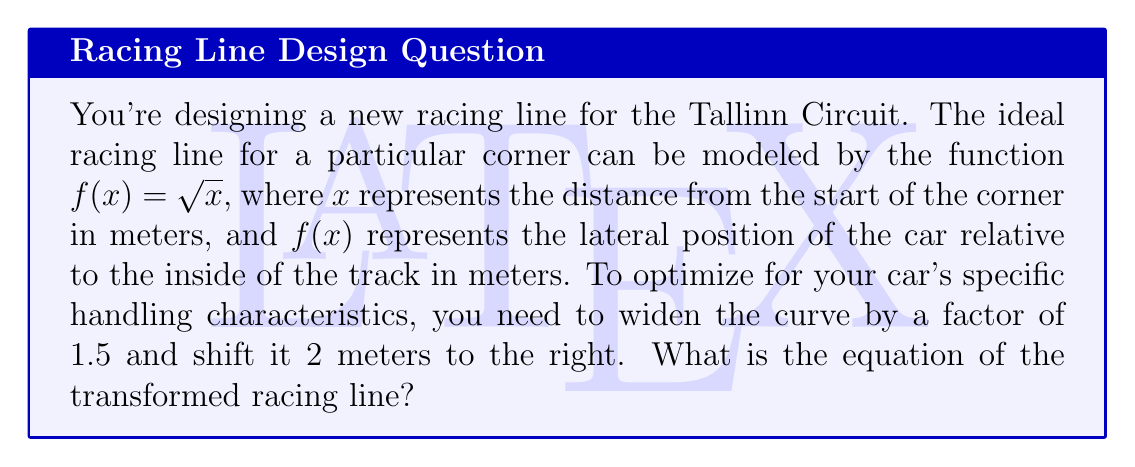Solve this math problem. To solve this problem, we need to apply two transformations to the original function $f(x) = \sqrt{x}$:

1. Widening the curve by a factor of 1.5:
   This is a horizontal stretch by a factor of 1.5. We achieve this by replacing $x$ with $\frac{x}{1.5}$ in the original function.
   
   $f(x) = \sqrt{\frac{x}{1.5}}$

2. Shifting the curve 2 meters to the right:
   This is a horizontal translation by 2 units to the right. We achieve this by replacing $x$ with $(x-2)$ in the function from step 1.

   $f(x) = \sqrt{\frac{(x-2)}{1.5}}$

Now, we can simplify this expression:

$$f(x) = \sqrt{\frac{x-2}{1.5}} = \sqrt{\frac{2(x-2)}{3}} = \frac{\sqrt{2}}{\sqrt{3}}\sqrt{x-2}$$

This is the equation of the transformed racing line, optimized for your car's handling characteristics on the Tallinn Circuit.
Answer: $f(x) = \frac{\sqrt{2}}{\sqrt{3}}\sqrt{x-2}$ 